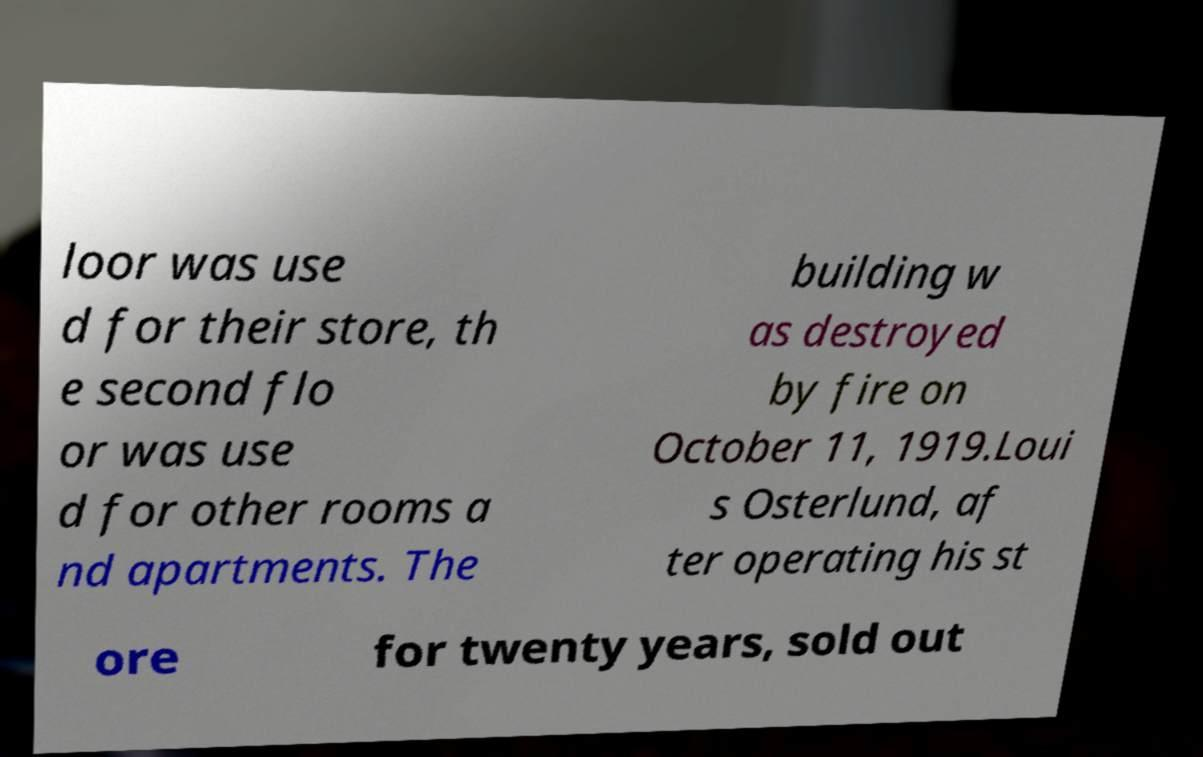What messages or text are displayed in this image? I need them in a readable, typed format. loor was use d for their store, th e second flo or was use d for other rooms a nd apartments. The building w as destroyed by fire on October 11, 1919.Loui s Osterlund, af ter operating his st ore for twenty years, sold out 